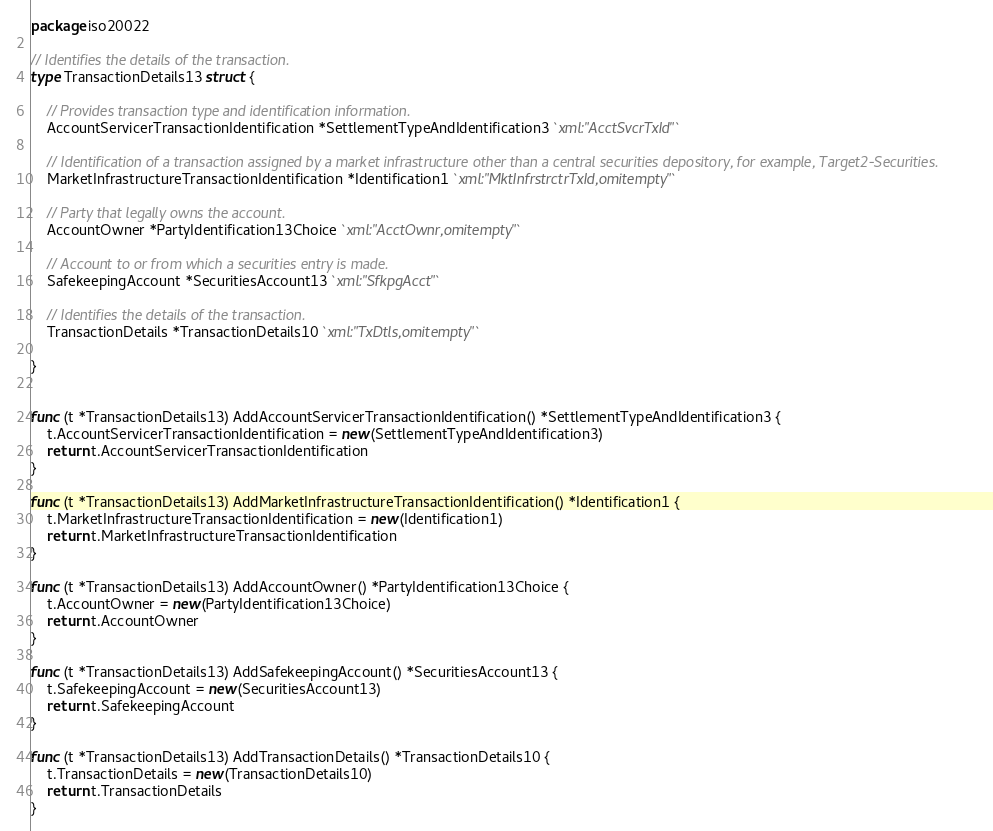Convert code to text. <code><loc_0><loc_0><loc_500><loc_500><_Go_>package iso20022

// Identifies the details of the transaction.
type TransactionDetails13 struct {

	// Provides transaction type and identification information.
	AccountServicerTransactionIdentification *SettlementTypeAndIdentification3 `xml:"AcctSvcrTxId"`

	// Identification of a transaction assigned by a market infrastructure other than a central securities depository, for example, Target2-Securities.
	MarketInfrastructureTransactionIdentification *Identification1 `xml:"MktInfrstrctrTxId,omitempty"`

	// Party that legally owns the account.
	AccountOwner *PartyIdentification13Choice `xml:"AcctOwnr,omitempty"`

	// Account to or from which a securities entry is made.
	SafekeepingAccount *SecuritiesAccount13 `xml:"SfkpgAcct"`

	// Identifies the details of the transaction.
	TransactionDetails *TransactionDetails10 `xml:"TxDtls,omitempty"`

}


func (t *TransactionDetails13) AddAccountServicerTransactionIdentification() *SettlementTypeAndIdentification3 {
	t.AccountServicerTransactionIdentification = new(SettlementTypeAndIdentification3)
	return t.AccountServicerTransactionIdentification
}

func (t *TransactionDetails13) AddMarketInfrastructureTransactionIdentification() *Identification1 {
	t.MarketInfrastructureTransactionIdentification = new(Identification1)
	return t.MarketInfrastructureTransactionIdentification
}

func (t *TransactionDetails13) AddAccountOwner() *PartyIdentification13Choice {
	t.AccountOwner = new(PartyIdentification13Choice)
	return t.AccountOwner
}

func (t *TransactionDetails13) AddSafekeepingAccount() *SecuritiesAccount13 {
	t.SafekeepingAccount = new(SecuritiesAccount13)
	return t.SafekeepingAccount
}

func (t *TransactionDetails13) AddTransactionDetails() *TransactionDetails10 {
	t.TransactionDetails = new(TransactionDetails10)
	return t.TransactionDetails
}

</code> 